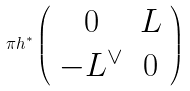<formula> <loc_0><loc_0><loc_500><loc_500>\pi h ^ { * } \left ( \begin{array} { c c } 0 & L \\ - L ^ { \vee } & 0 \end{array} \right )</formula> 